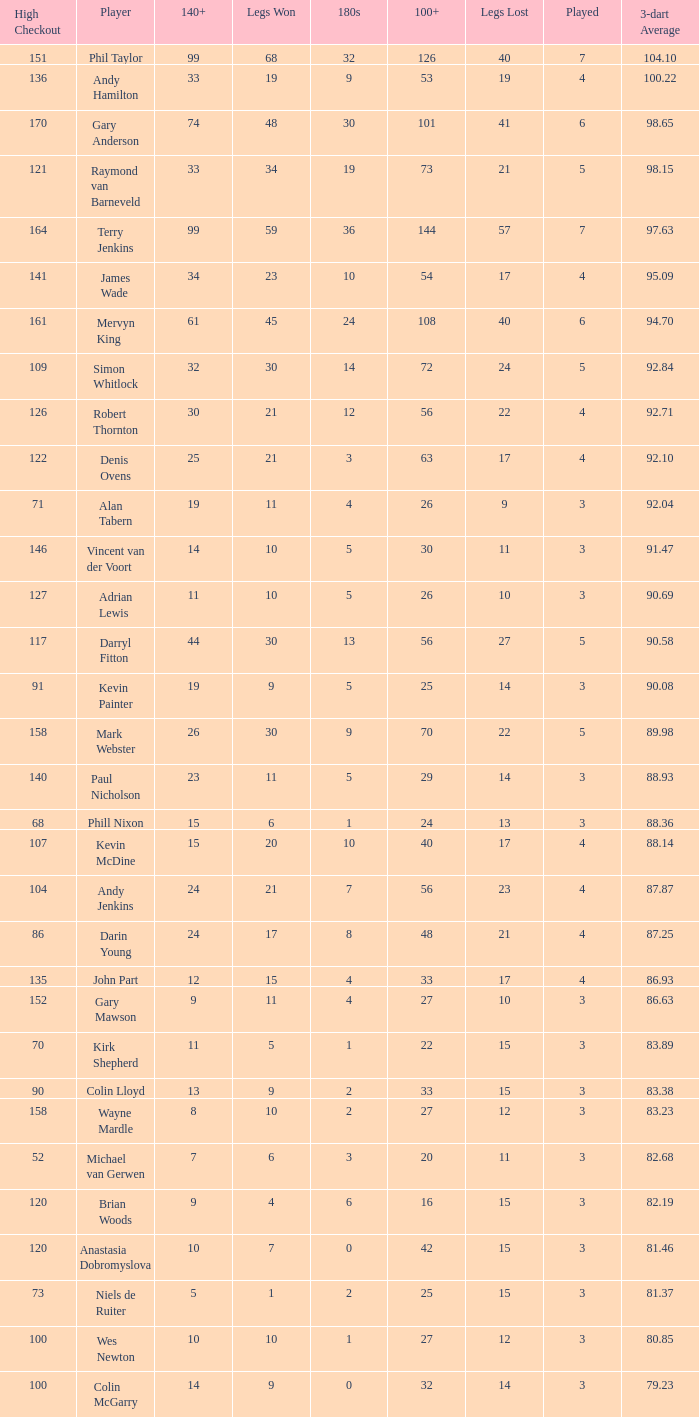What is the played number when the high checkout is 135? 4.0. 